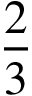Convert formula to latex. <formula><loc_0><loc_0><loc_500><loc_500>\frac { 2 } { 3 }</formula> 